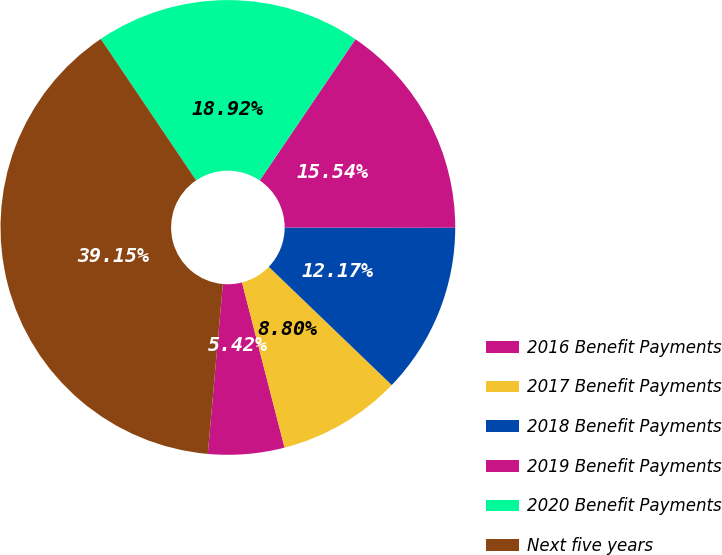Convert chart. <chart><loc_0><loc_0><loc_500><loc_500><pie_chart><fcel>2016 Benefit Payments<fcel>2017 Benefit Payments<fcel>2018 Benefit Payments<fcel>2019 Benefit Payments<fcel>2020 Benefit Payments<fcel>Next five years<nl><fcel>5.42%<fcel>8.8%<fcel>12.17%<fcel>15.54%<fcel>18.92%<fcel>39.15%<nl></chart> 